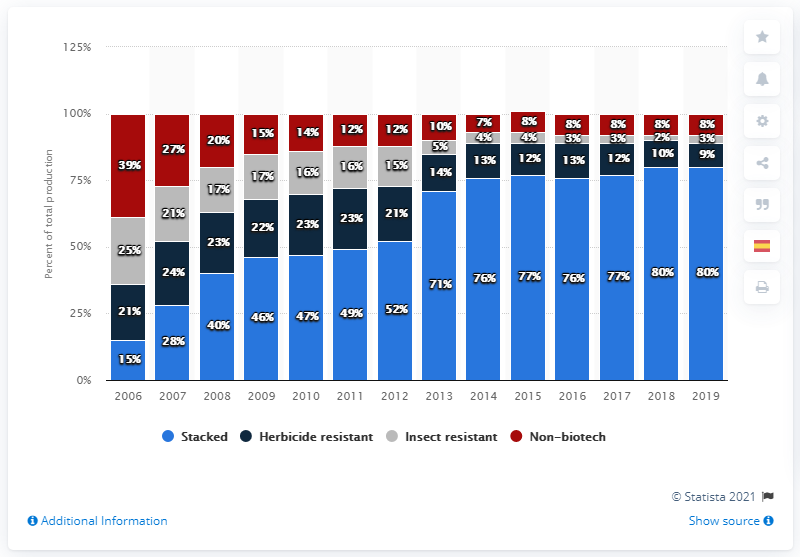Draw attention to some important aspects in this diagram. The highest stacked and lowest non-biotech attribute for a given product is 79. Stacked was a popular trend in 2015, and its percentage value is estimated to be around 77%. 